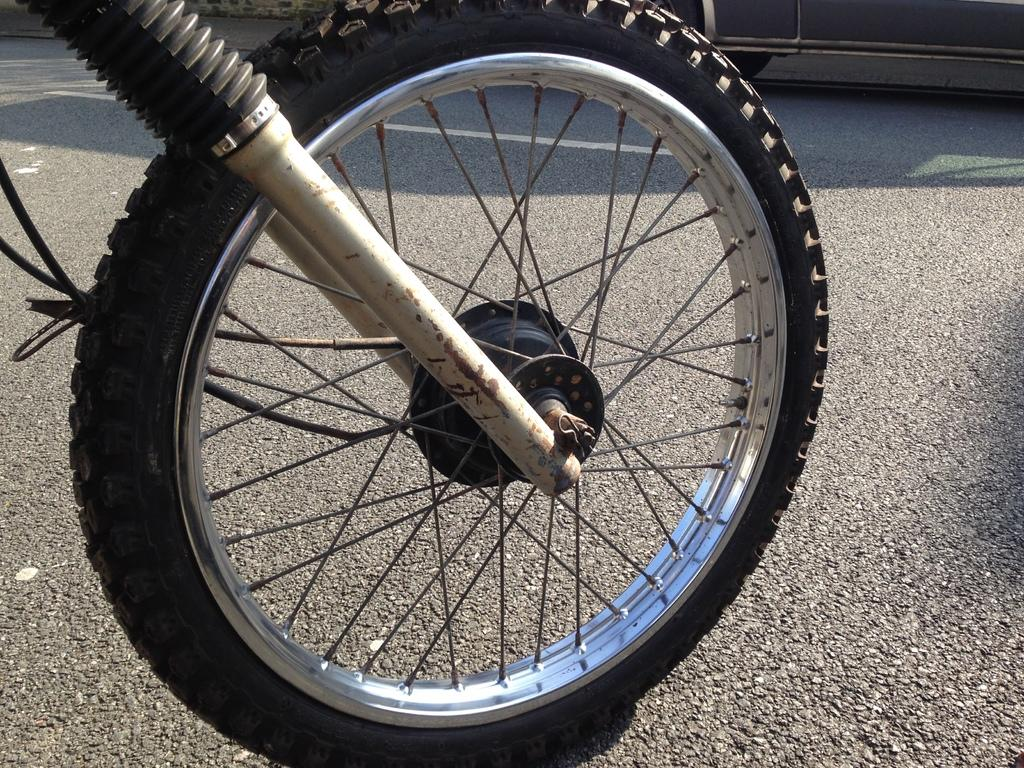What object related to a vehicle can be seen in the image? There is a tire of a vehicle in the image. What type of surface is visible at the bottom of the image? There is a road visible at the bottom of the image. What type of bit is being used to transport the tire in the image? There is no bit or transportation method visible in the image; it only shows a tire and a road. 